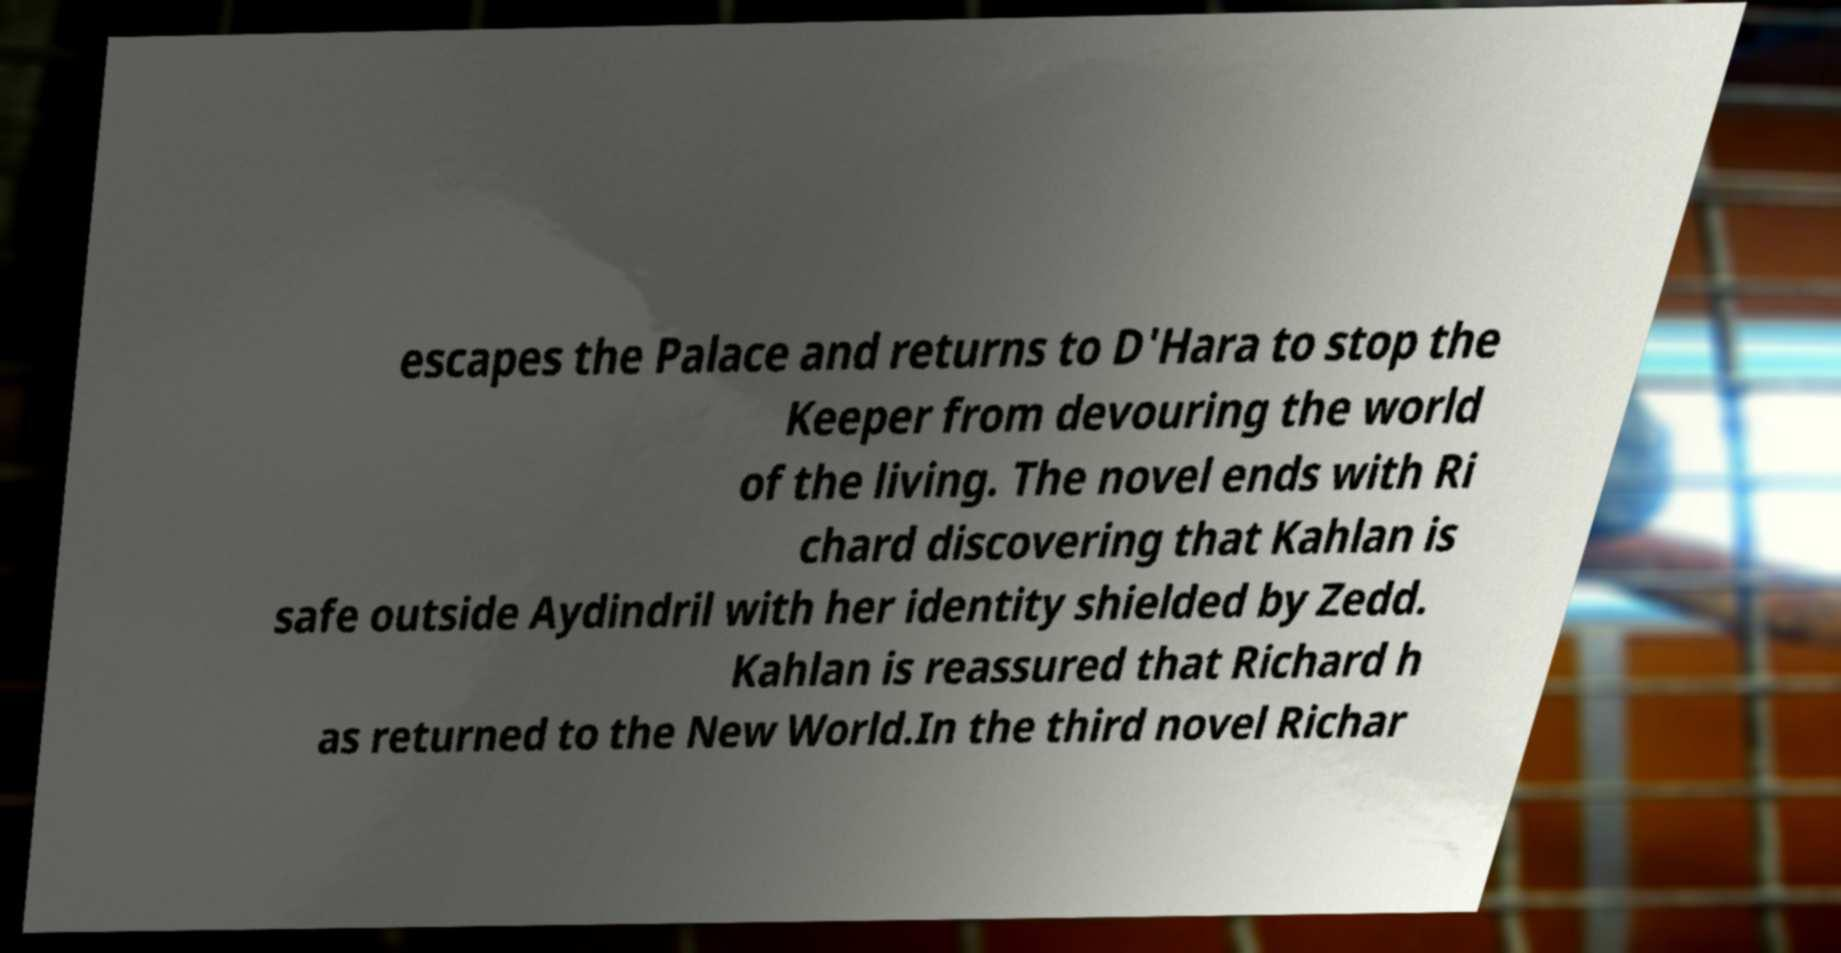Could you assist in decoding the text presented in this image and type it out clearly? escapes the Palace and returns to D'Hara to stop the Keeper from devouring the world of the living. The novel ends with Ri chard discovering that Kahlan is safe outside Aydindril with her identity shielded by Zedd. Kahlan is reassured that Richard h as returned to the New World.In the third novel Richar 